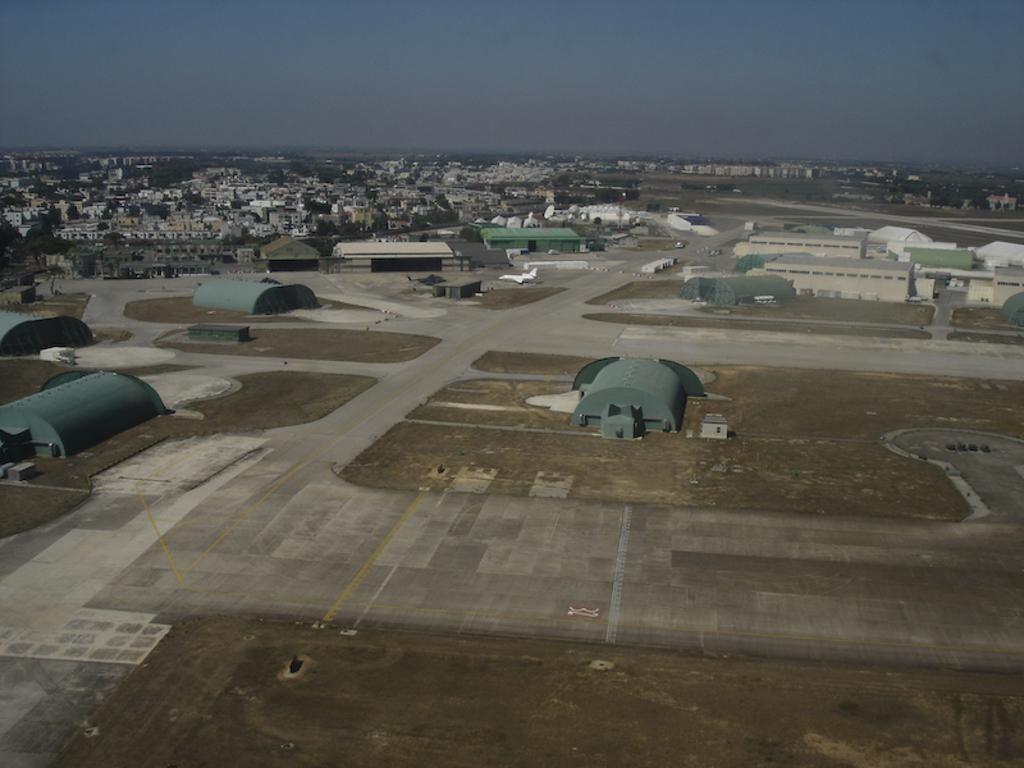Can you describe this image briefly? This is a aerial view. In this image we can see buildings, sheds, aeroplane, runway, roads, grass, trees, sky and clouds. 